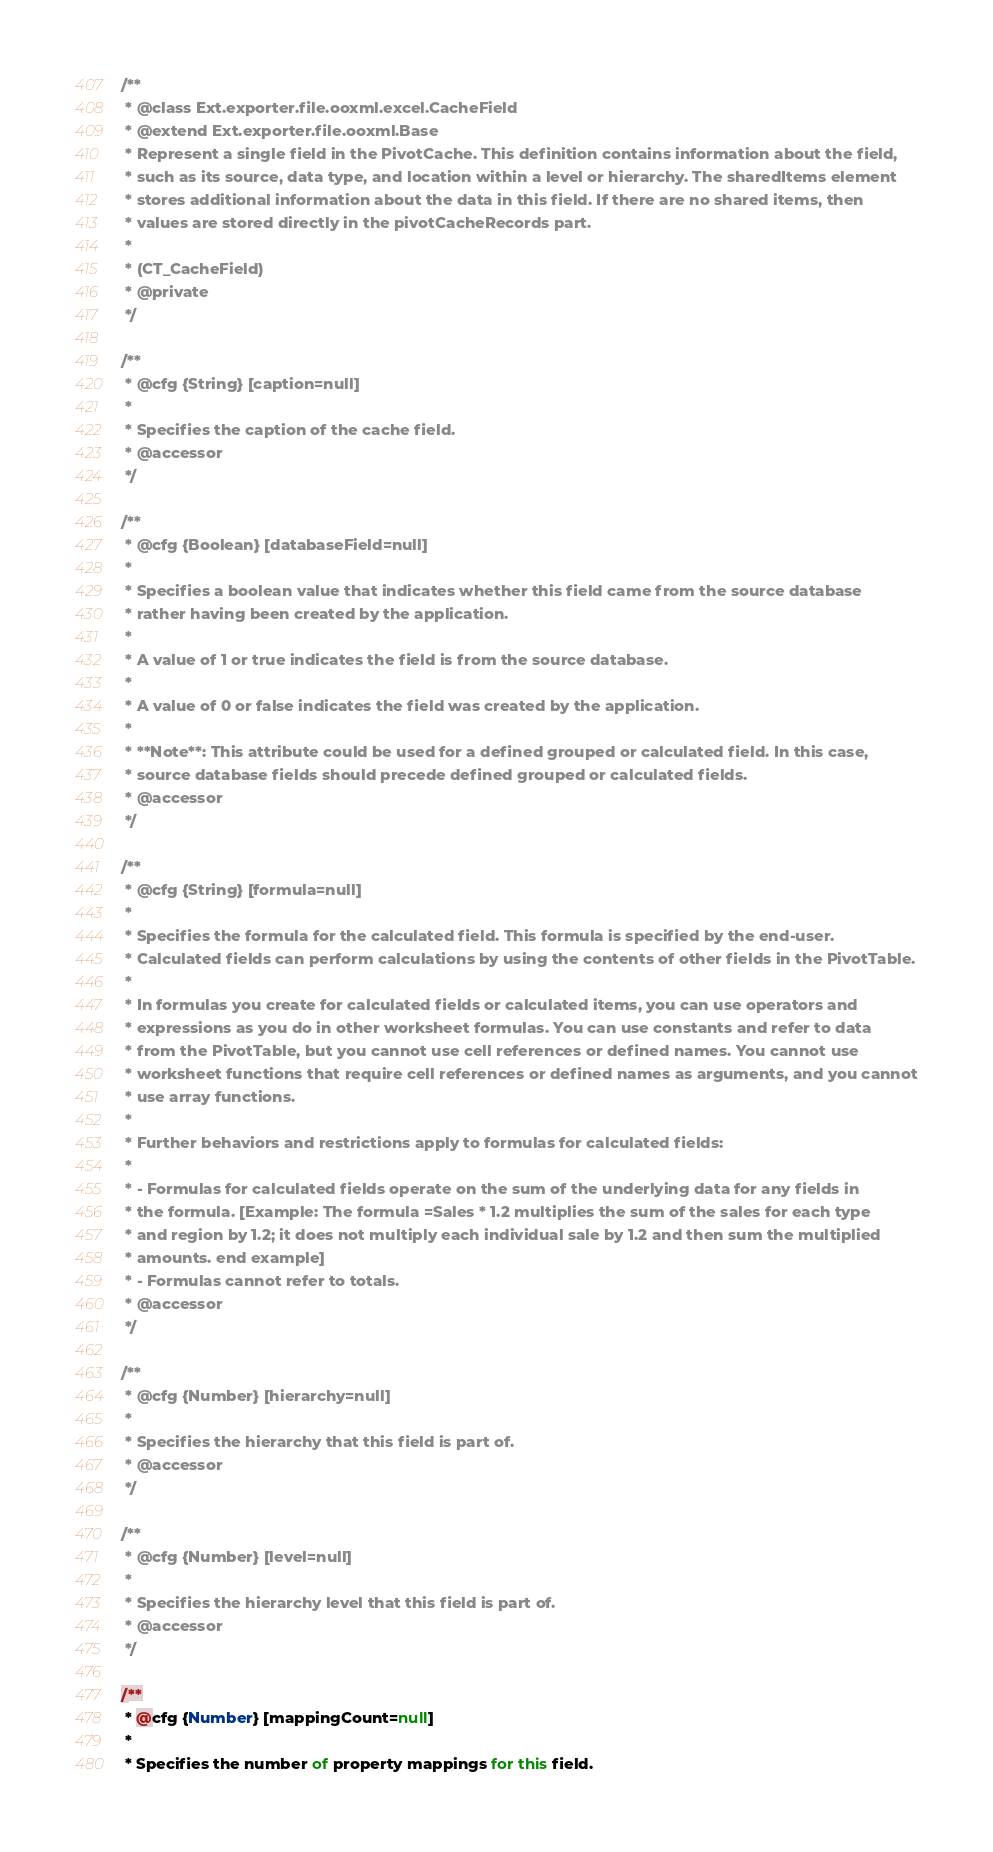<code> <loc_0><loc_0><loc_500><loc_500><_JavaScript_>/**
 * @class Ext.exporter.file.ooxml.excel.CacheField
 * @extend Ext.exporter.file.ooxml.Base
 * Represent a single field in the PivotCache. This definition contains information about the field,
 * such as its source, data type, and location within a level or hierarchy. The sharedItems element
 * stores additional information about the data in this field. If there are no shared items, then
 * values are stored directly in the pivotCacheRecords part.
 *
 * (CT_CacheField)
 * @private
 */

/**
 * @cfg {String} [caption=null]
 *
 * Specifies the caption of the cache field.
 * @accessor
 */

/**
 * @cfg {Boolean} [databaseField=null]
 *
 * Specifies a boolean value that indicates whether this field came from the source database
 * rather having been created by the application.
 *
 * A value of 1 or true indicates the field is from the source database.
 *
 * A value of 0 or false indicates the field was created by the application.
 *
 * **Note**: This attribute could be used for a defined grouped or calculated field. In this case,
 * source database fields should precede defined grouped or calculated fields.
 * @accessor
 */

/**
 * @cfg {String} [formula=null]
 *
 * Specifies the formula for the calculated field. This formula is specified by the end-user.
 * Calculated fields can perform calculations by using the contents of other fields in the PivotTable.
 *
 * In formulas you create for calculated fields or calculated items, you can use operators and
 * expressions as you do in other worksheet formulas. You can use constants and refer to data
 * from the PivotTable, but you cannot use cell references or defined names. You cannot use
 * worksheet functions that require cell references or defined names as arguments, and you cannot
 * use array functions.
 *
 * Further behaviors and restrictions apply to formulas for calculated fields:
 *
 * - Formulas for calculated fields operate on the sum of the underlying data for any fields in
 * the formula. [Example: The formula =Sales * 1.2 multiplies the sum of the sales for each type
 * and region by 1.2; it does not multiply each individual sale by 1.2 and then sum the multiplied
 * amounts. end example]
 * - Formulas cannot refer to totals.
 * @accessor
 */

/**
 * @cfg {Number} [hierarchy=null]
 *
 * Specifies the hierarchy that this field is part of.
 * @accessor
 */

/**
 * @cfg {Number} [level=null]
 *
 * Specifies the hierarchy level that this field is part of.
 * @accessor
 */

/**
 * @cfg {Number} [mappingCount=null]
 *
 * Specifies the number of property mappings for this field.</code> 